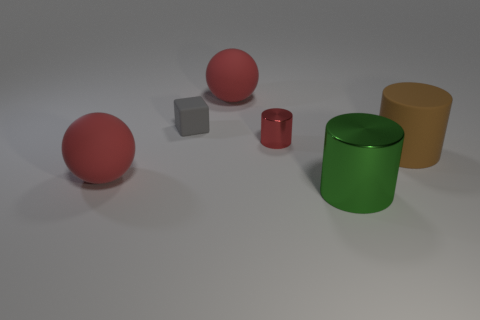Are there any other things that are the same shape as the tiny gray object?
Offer a terse response. No. There is a green metal thing in front of the tiny matte thing; is there a cylinder that is in front of it?
Your answer should be compact. No. What number of matte objects are in front of the red shiny thing and on the left side of the brown matte cylinder?
Offer a terse response. 1. What number of tiny gray cubes are made of the same material as the small red object?
Offer a very short reply. 0. What size is the rubber ball that is to the right of the red rubber object left of the small gray matte cube?
Your answer should be compact. Large. Are there any other small red objects of the same shape as the small rubber object?
Ensure brevity in your answer.  No. Does the red rubber ball in front of the brown thing have the same size as the shiny cylinder behind the big brown cylinder?
Your answer should be very brief. No. Is the number of green metal cylinders to the right of the large metallic thing less than the number of balls behind the tiny gray thing?
Provide a short and direct response. Yes. There is a big rubber object left of the gray matte block; what color is it?
Provide a short and direct response. Red. Is the small metal cylinder the same color as the large metallic thing?
Ensure brevity in your answer.  No. 